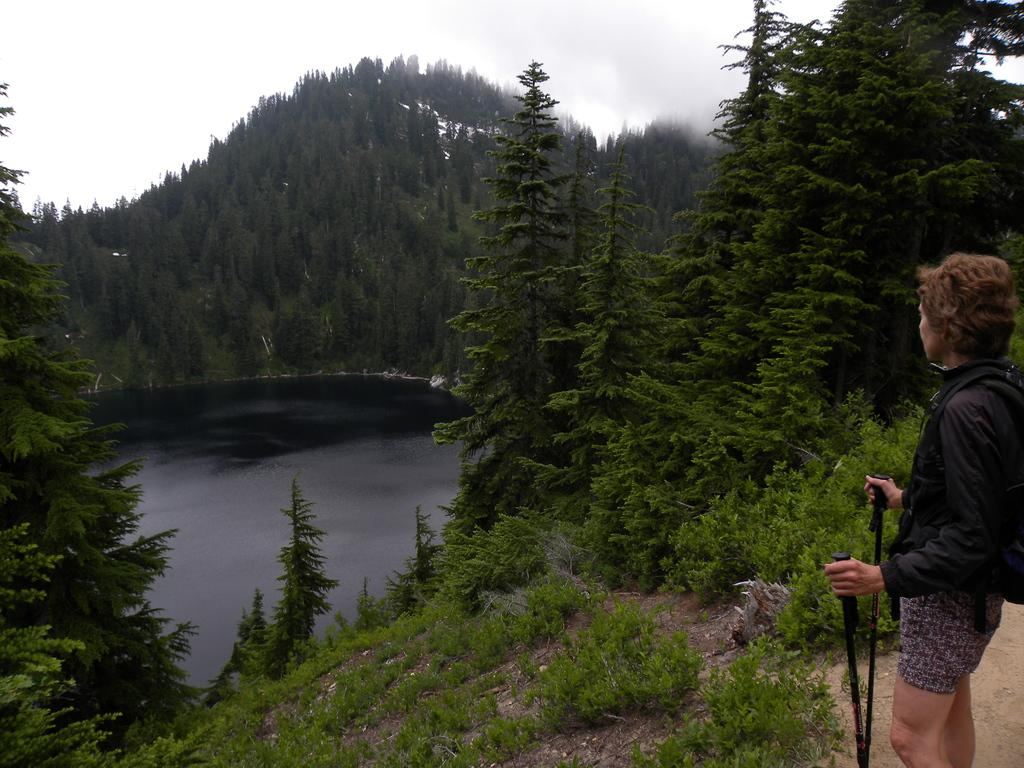Where was the image taken? The image is taken outdoors. Who is present in the image? There is a woman in the image. What is the woman wearing? The woman is wearing a black jacket. What is the woman standing on? The woman is standing on the floor. What is the woman holding in her hands? The woman is holding two sticks. What can be seen in front of the woman? There are trees, water, and fog in front of the woman. What type of wristwatch is the woman wearing in the image? There is no wristwatch visible in the image. What kind of teeth can be seen in the woman's mouth in the image? The image does not show the woman's teeth, so it is not possible to determine what kind of teeth she might have. 